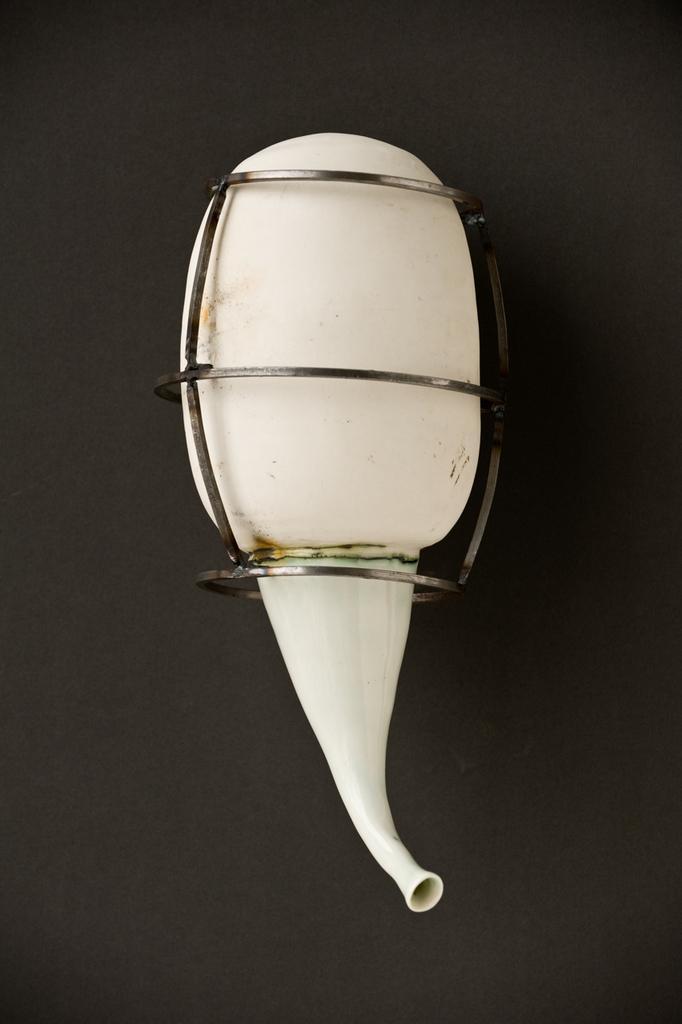How would you summarize this image in a sentence or two? In the center of the image there is a white color object on the black surface. 